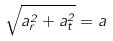Convert formula to latex. <formula><loc_0><loc_0><loc_500><loc_500>\sqrt { a _ { r } ^ { 2 } + a _ { t } ^ { 2 } } = a</formula> 